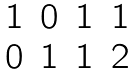<formula> <loc_0><loc_0><loc_500><loc_500>\begin{matrix} 1 & 0 & 1 & 1 \\ 0 & 1 & 1 & 2 \end{matrix}</formula> 